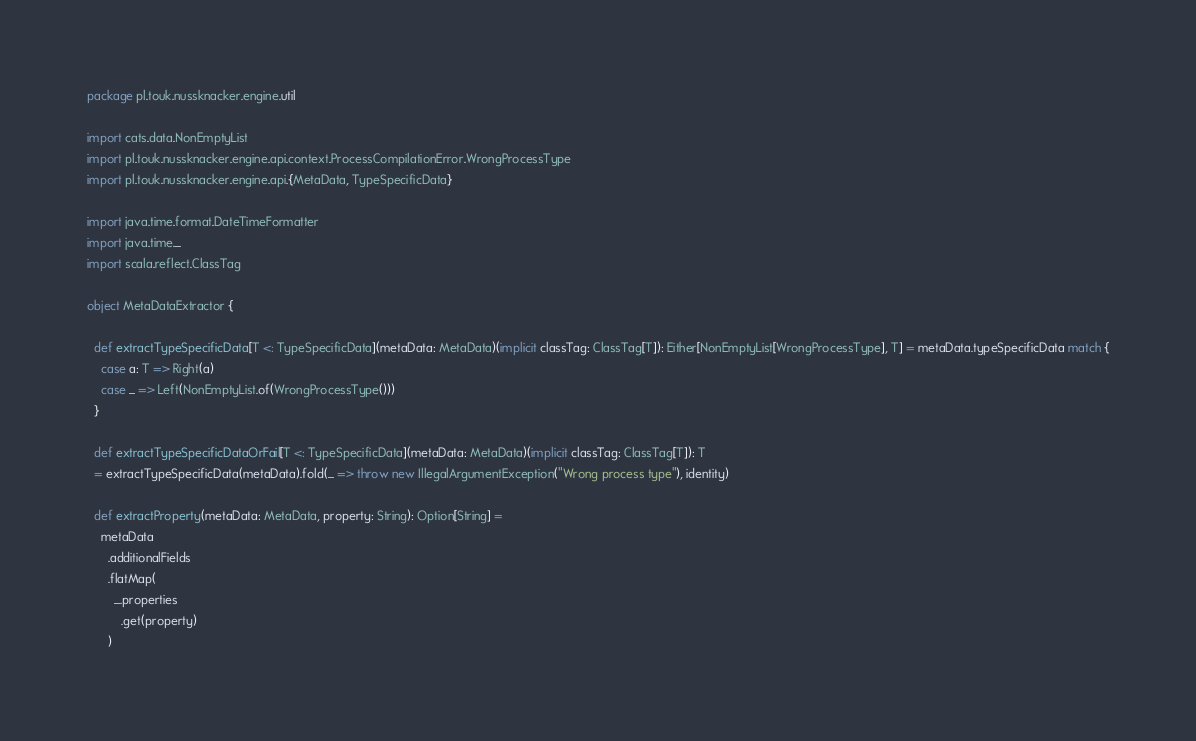<code> <loc_0><loc_0><loc_500><loc_500><_Scala_>package pl.touk.nussknacker.engine.util

import cats.data.NonEmptyList
import pl.touk.nussknacker.engine.api.context.ProcessCompilationError.WrongProcessType
import pl.touk.nussknacker.engine.api.{MetaData, TypeSpecificData}

import java.time.format.DateTimeFormatter
import java.time._
import scala.reflect.ClassTag

object MetaDataExtractor {

  def extractTypeSpecificData[T <: TypeSpecificData](metaData: MetaData)(implicit classTag: ClassTag[T]): Either[NonEmptyList[WrongProcessType], T] = metaData.typeSpecificData match {
    case a: T => Right(a)
    case _ => Left(NonEmptyList.of(WrongProcessType()))
  }

  def extractTypeSpecificDataOrFail[T <: TypeSpecificData](metaData: MetaData)(implicit classTag: ClassTag[T]): T
  = extractTypeSpecificData(metaData).fold(_ => throw new IllegalArgumentException("Wrong process type"), identity)

  def extractProperty(metaData: MetaData, property: String): Option[String] =
    metaData
      .additionalFields
      .flatMap(
        _.properties
          .get(property)
      )
</code> 